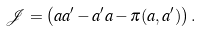<formula> <loc_0><loc_0><loc_500><loc_500>\mathcal { J } = \left ( a a ^ { \prime } - a ^ { \prime } a - \pi ( a , a ^ { \prime } ) \right ) .</formula> 